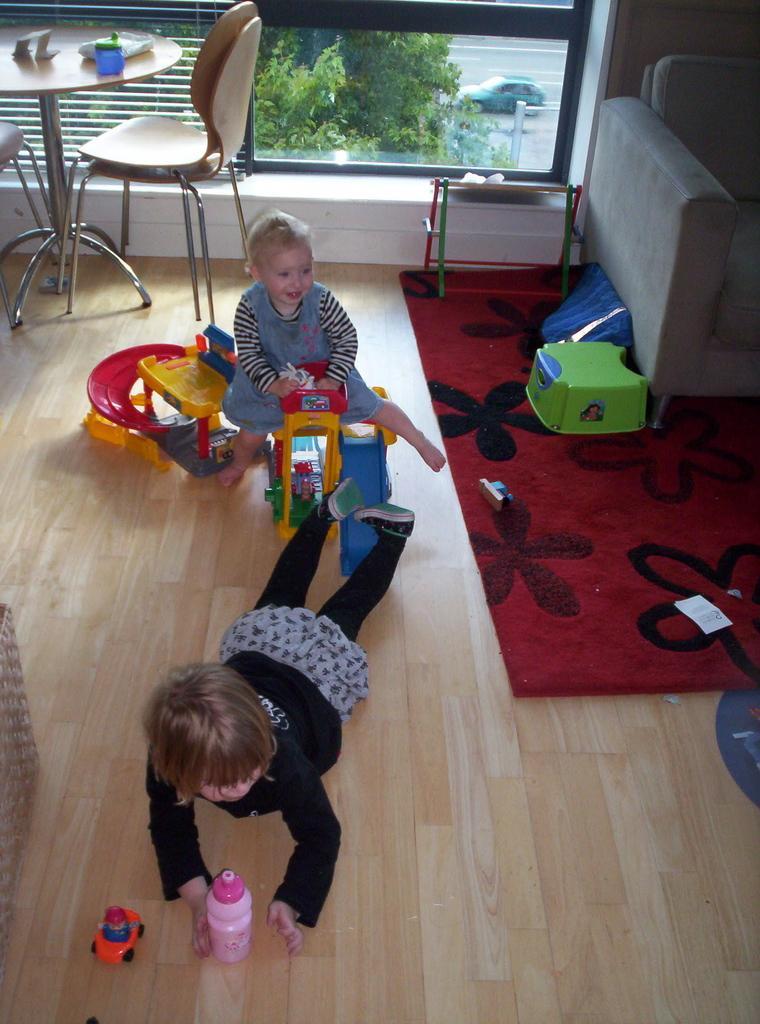Please provide a concise description of this image. there are two children in this picture, playing with toys on the floor. There is a carpet and a sofa in the right side. We can observe a table and chairs in the top left corner of the image. In the background there are some trees and car parked on the road. 